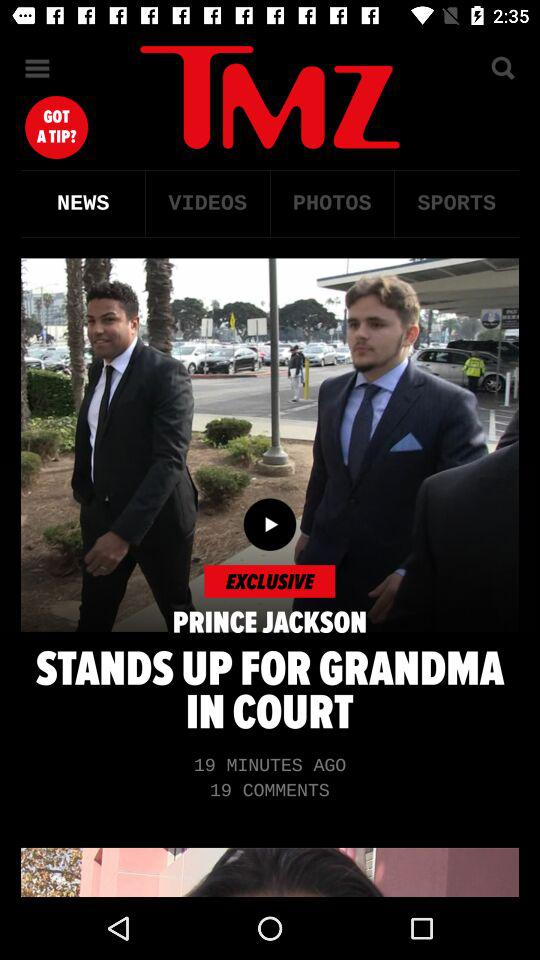When was the video posted? The video was posted 19 minutes ago. 